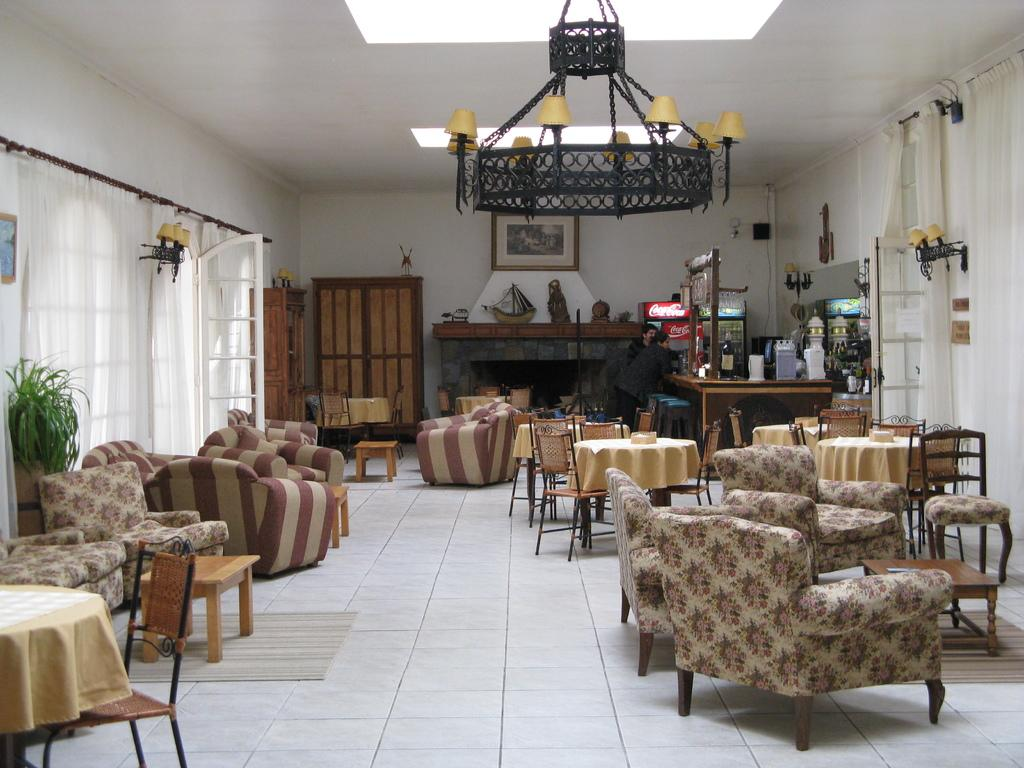What type of furniture is present in the image? There are couches, chairs, and tables in the image. What other objects can be seen in the image? There are lamps and curtains in the image. Can you describe the lighting in the room? The presence of lamps suggests that there is artificial lighting in the room. What type of potato is sitting on the couch in the image? There is no potato present in the image; it only features furniture and other objects. 